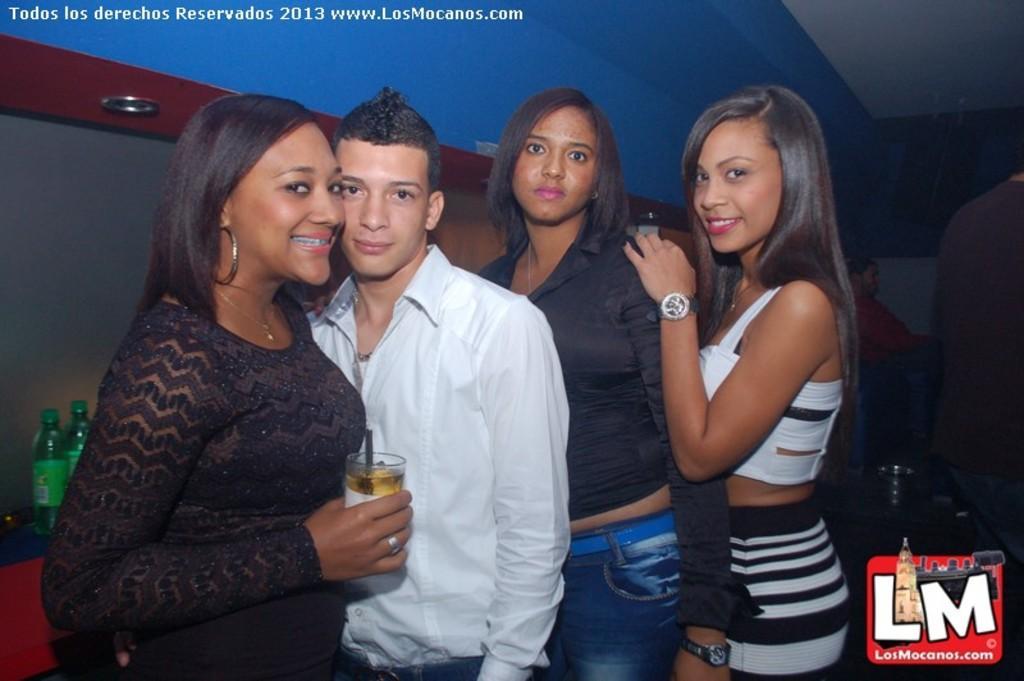In one or two sentences, can you explain what this image depicts? In this picture I can see four persons standing , a person holding a glass with a straw, and there are lights, people standing, there are bottles on the cabinet, and there are watermarks on the image. 